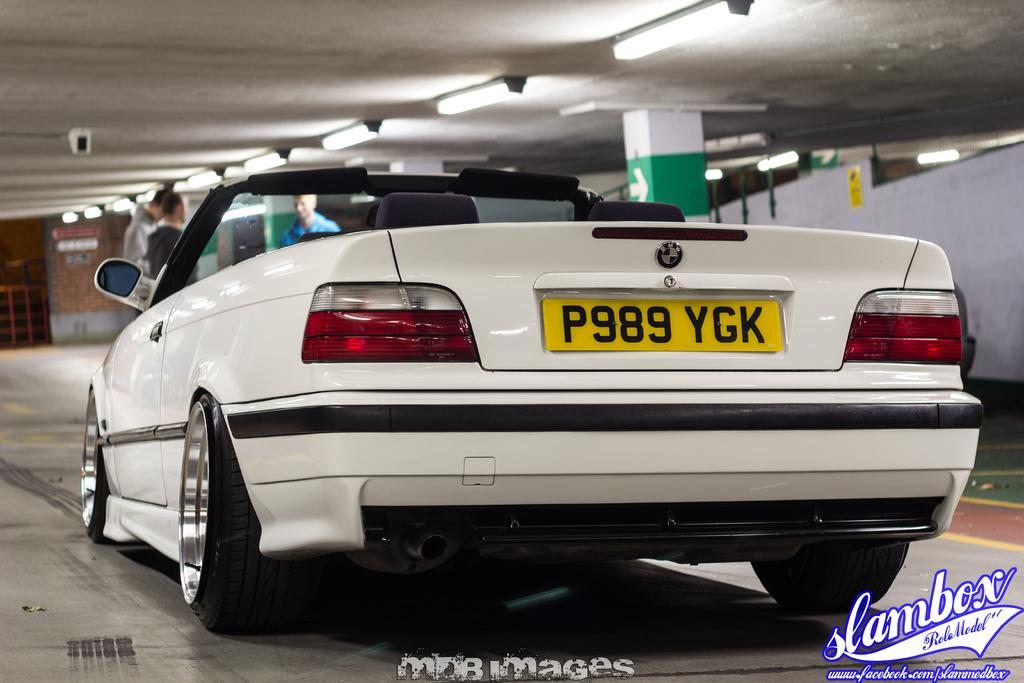What is the main subject of the image? There is a vehicle in the image. Can you describe the color of the vehicle? The vehicle is white. What can be seen in the background of the image? There is a group of people, lights, pillars, and a brown wall visible in the background. How many kitties are playing with a quill in the image? There are no kitties or quills present in the image. What type of army is depicted in the image? There is no army depicted in the image; it features a white vehicle and various elements in the background. 